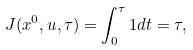Convert formula to latex. <formula><loc_0><loc_0><loc_500><loc_500>J ( x ^ { 0 } , u , \tau ) = \int _ { 0 } ^ { \tau } 1 d t = \tau ,</formula> 